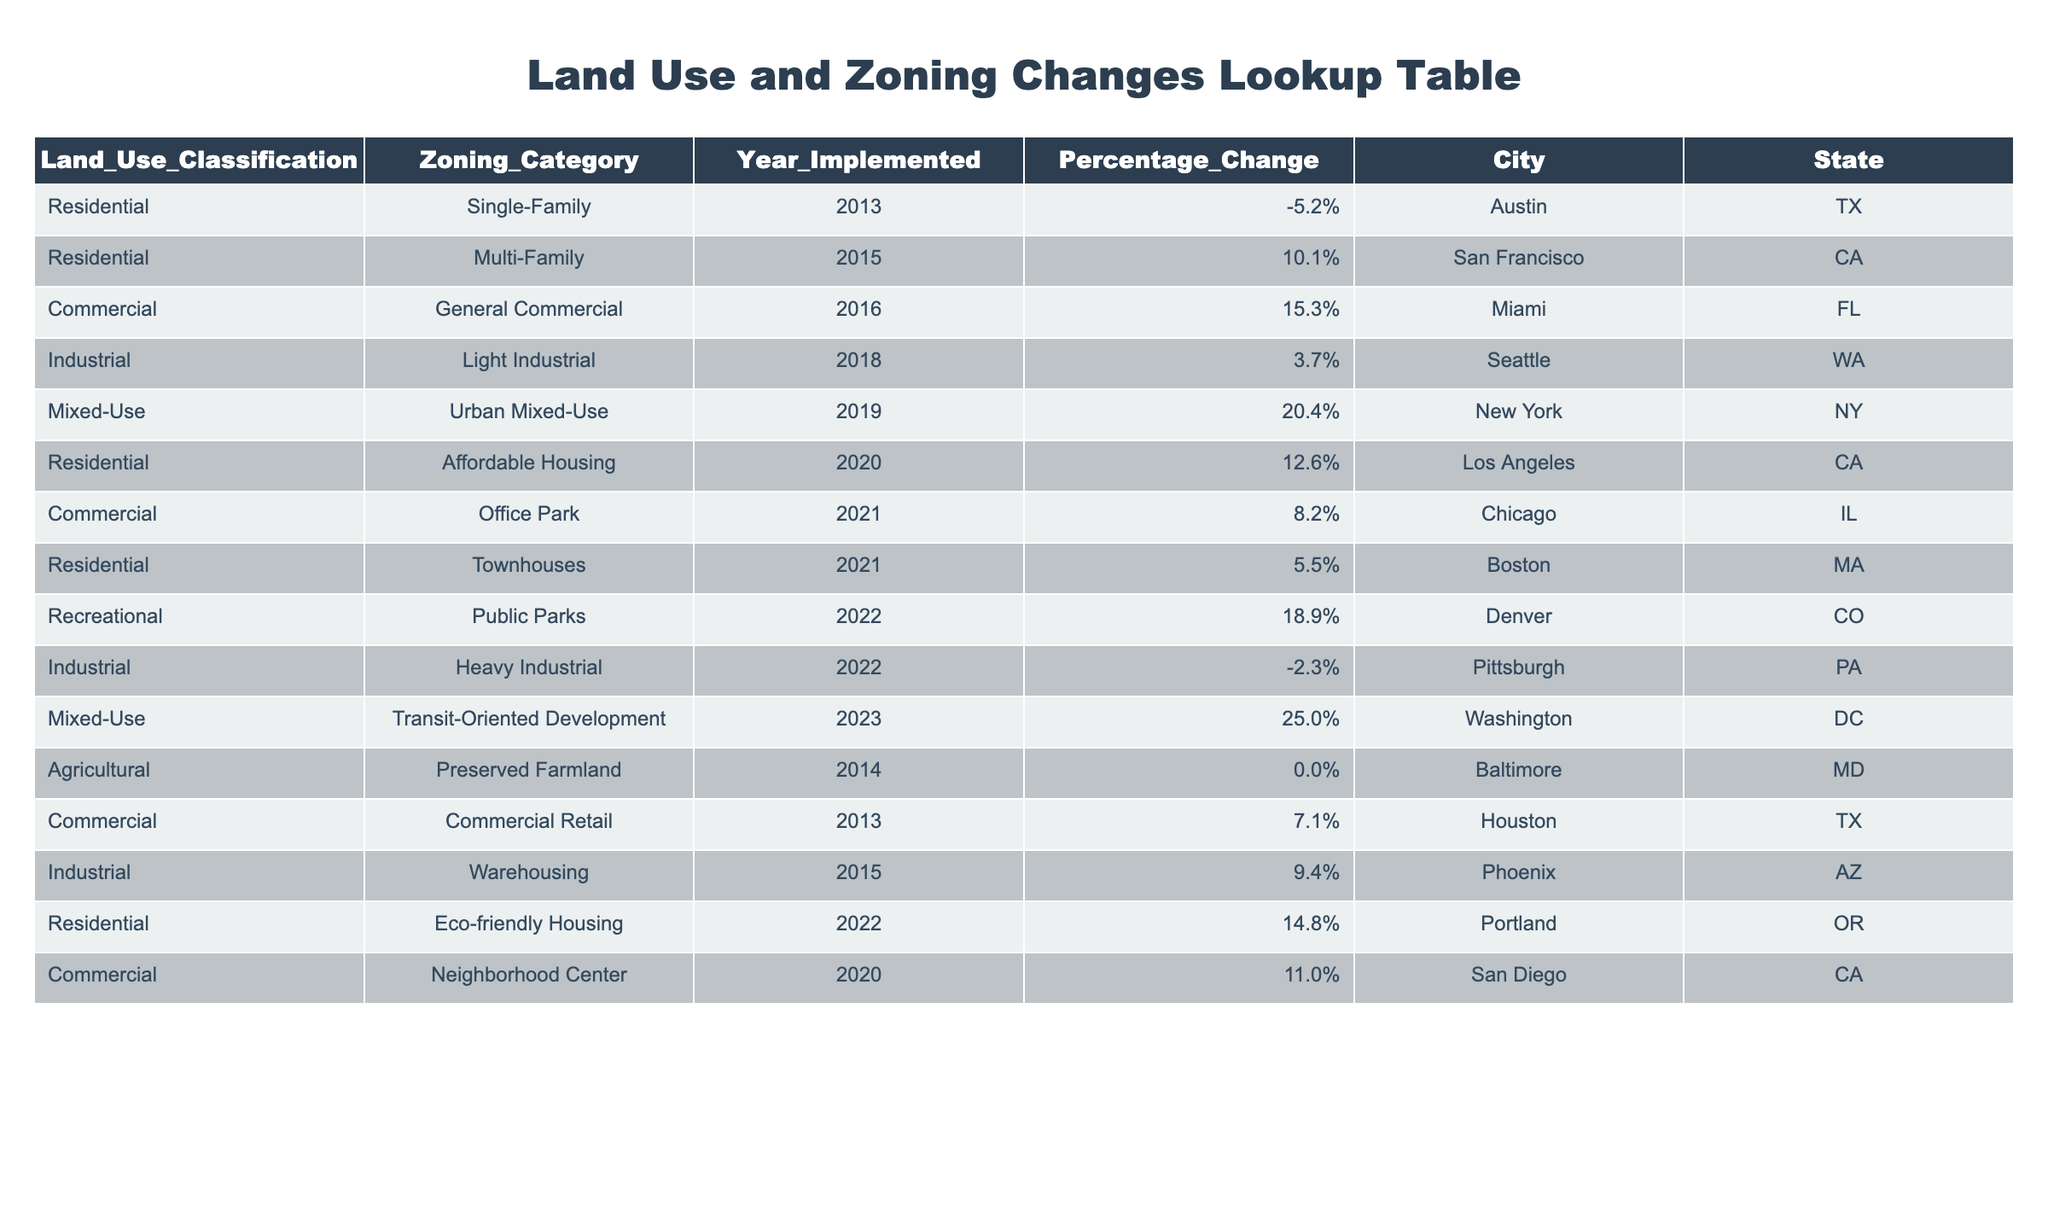What was the zoning category implemented in Denver, CO in 2022? The table shows that in 2022, Denver, CO had a zoning category of Public Parks under the Land Use Classification Recreational.
Answer: Public Parks How many zoning categories were implemented in 2021? By looking at the table, we can see there are two rows for the year 2021: Office Park in Chicago, IL and Townhouses in Boston, MA, so the count is 2.
Answer: 2 What is the highest percentage change in zoning category observed in the table, and where was it implemented? The highest percentage change is 25.0%, which was implemented in Washington, DC under the Mixed-Use classification for Transit-Oriented Development in 2023.
Answer: 25.0% in Washington, DC Was there any negative percentage change in zoning categories? Looking through the table data, there are two instances of negative percentage changes: -5.2% for Single-Family in Austin, TX and -2.3% for Heavy Industrial in Pittsburgh, PA. Thus, the answer is yes.
Answer: Yes What is the average percentage change for all zoning categories implemented in 2020? From the table, the percentage changes for zoning categories implemented in 2020 are 12.6% for Affordable Housing in Los Angeles, CA and 11.0% for Neighborhood Center in San Diego, CA. To find the average, we calculate (12.6 + 11.0) / 2 = 11.8%.
Answer: 11.8% Which city had the first implementation of a Mixed-Use zoning category? The table reveals that the first implementation of a Mixed-Use zoning category was in New York, NY with Urban Mixed-Use, and it occurred in 2019.
Answer: New York, NY How many cities saw an increase in zoning percentage change above 10%? By reviewing the table, we identify the cities with percentage changes above 10%: San Francisco (10.1%), Miami (15.3%), Los Angeles (12.6%), Chicago (8.2%), Boston (5.5%), Denver (18.9%), San Diego (11.0%), and Washington, DC (25.0%). Counting these entries gives us 7 cities.
Answer: 7 cities What land use classification had a zoning category implemented in 2013, and what was its percentage change? According to the table, in 2013, the land use classification Residential had a zoning category of Single-Family with a percentage change of -5.2%.
Answer: Single-Family, -5.2% How does the percentage change of the Residential zoning categories compare to Commercial zoning categories implemented in 2021? There are three Residential zoning category entries to consider: -5.2%, 10.1% (from 2015), 12.6% (from 2020), and 5.5%. The average is (-5.2 + 10.1 + 12.6 + 5.5) / 4 = 5.25%. For Commercial zoning categories in 2021, there is only one entry, which is 8.2%. Hence, commercial zoning categories have a higher percentage change than the average of residential zoning categories.
Answer: Commercial zoning is higher 